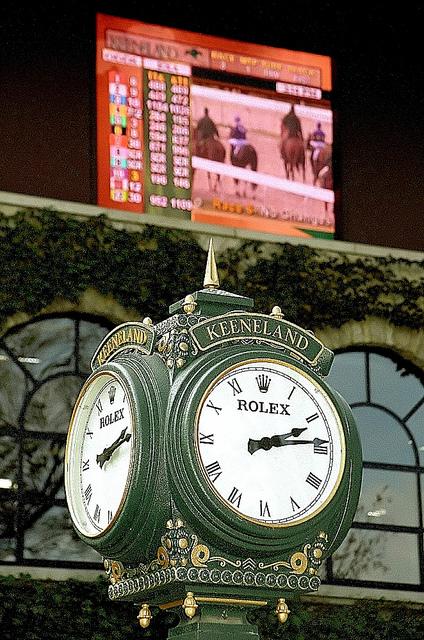Is that a wristwatch?
Quick response, please. No. What year is it?
Quick response, please. 2017. What baseball team is highlighted here?
Concise answer only. None. What kind of bird is the team named after?
Be succinct. Cardinal. How many clocks are shown?
Be succinct. 2. What time is it?
Answer briefly. 2:14. What is the clock used for?
Keep it brief. Time. Are there two clocks in this photo?
Quick response, please. Yes. 